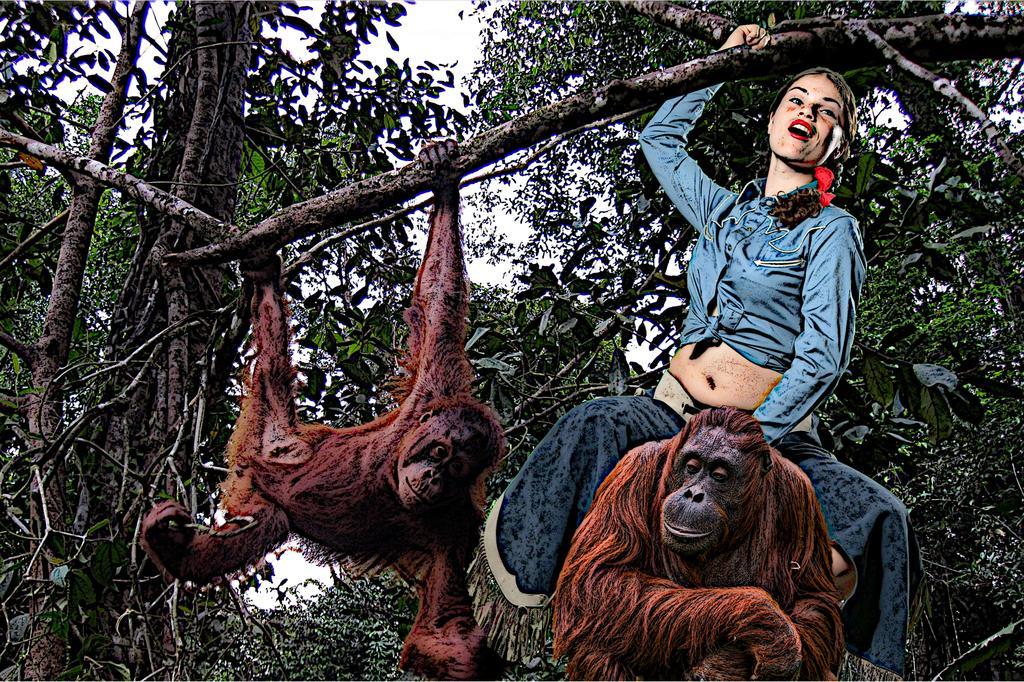Can you describe this image briefly? This is an edited image in this image there is one woman and two monkeys, and in the background there are some trees and sky and the woman is holding a stick. 